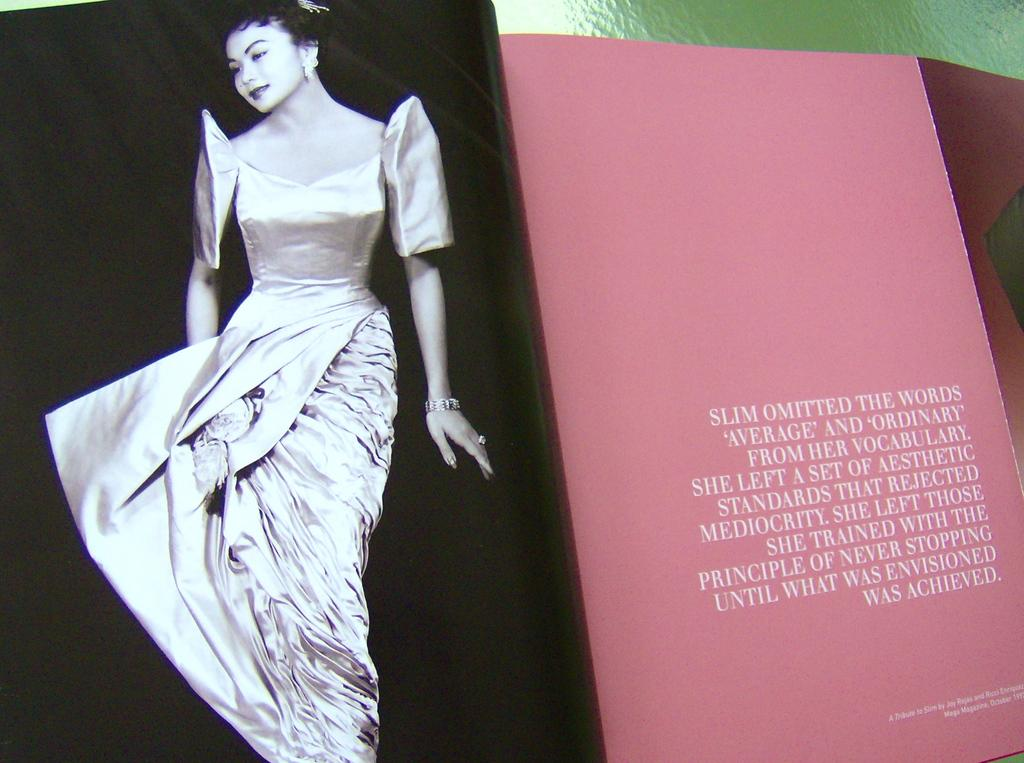<image>
Write a terse but informative summary of the picture. A pink magazine page says that slim omitted the words average and ordinary from her vocabulary. 